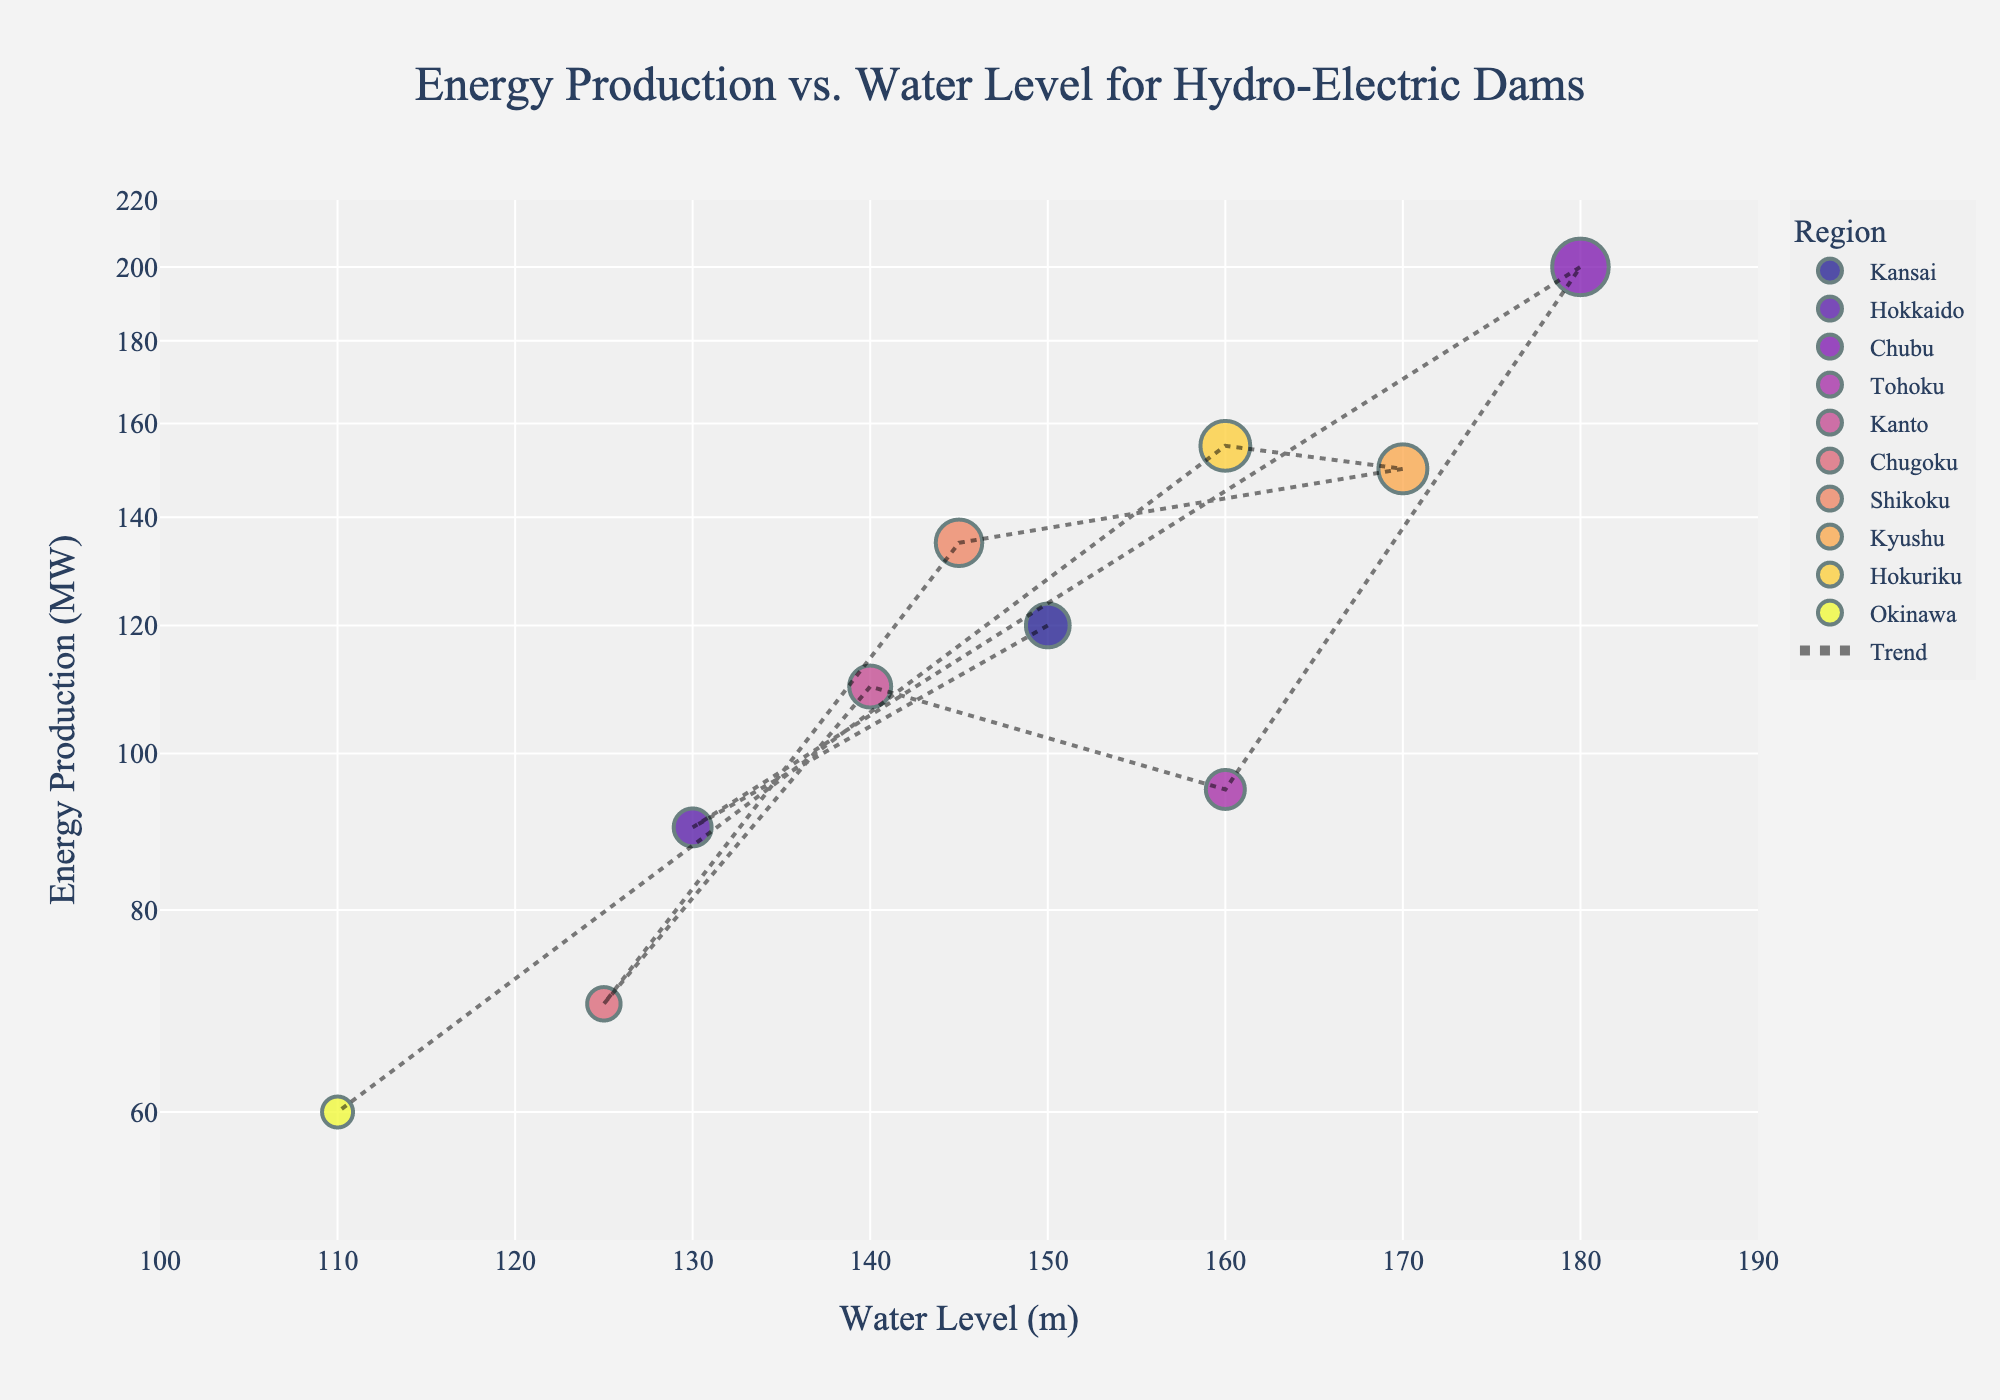what is the title of the figure? The title is usually displayed at the top of the figure. It provides an overview of what the plot is about.
Answer: Energy Production vs. Water Level for Hydro-Electric Dams how many regions are represented in the figure? Each data point is color-coded by region. By checking the different colors/legends, you can count the number of unique regions.
Answer: 9 which dam has the highest energy production? By looking at the y-axis, identify the point with the highest value and see the hover name for that point.
Answer: Kurobe Dam what is the water level for Ikari Dam? Look at the x-axis and find the point named Ikari Dam for its water level.
Answer: 150 meters how many dams have energy production above 100 MW? Check the y-axis (log scale) and count the number of points that are above 100 MW.
Answer: 5 which region has the dam with the lowest water level? Check the x-axis for the lowest value data point and identify its region from the hover information.
Answer: Okinawa compare the energy production between Uchinokura Dam and Kin Dam. Which one produces more energy? Locate both points in the plot and compare their y-axis values. Uchinokura Dam should be higher than Kin Dam.
Answer: Uchinokura Dam what is the average water level of dams in the Kansai and Tohoku regions combined? Identify and sum the water levels of dams in Kansai (150) and Tohoku (160), then divide by the number of dams (2).
Answer: 155 meters describe the trend line added to the figure. How does energy production generally relate to water level? Look at the overall direction of the trend line. It shows whether production increases or decreases with the rising water level.
Answer: Generally increasing is there any significant outlier in terms of energy production? Inspect the data point far from the general concentration; it's based on the y-axis values.
Answer: Yes, Kurobe Dam with 200 MW 